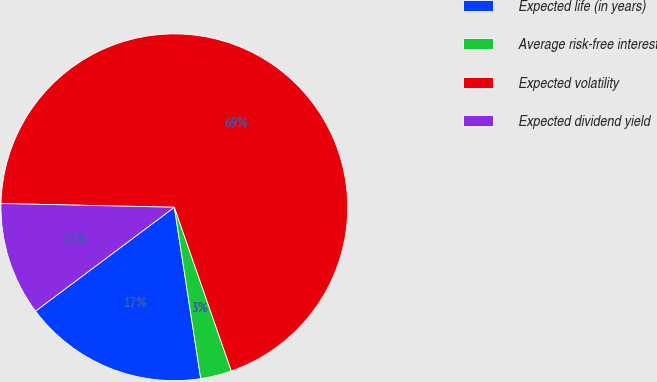Convert chart. <chart><loc_0><loc_0><loc_500><loc_500><pie_chart><fcel>Expected life (in years)<fcel>Average risk-free interest<fcel>Expected volatility<fcel>Expected dividend yield<nl><fcel>17.21%<fcel>2.9%<fcel>69.33%<fcel>10.57%<nl></chart> 